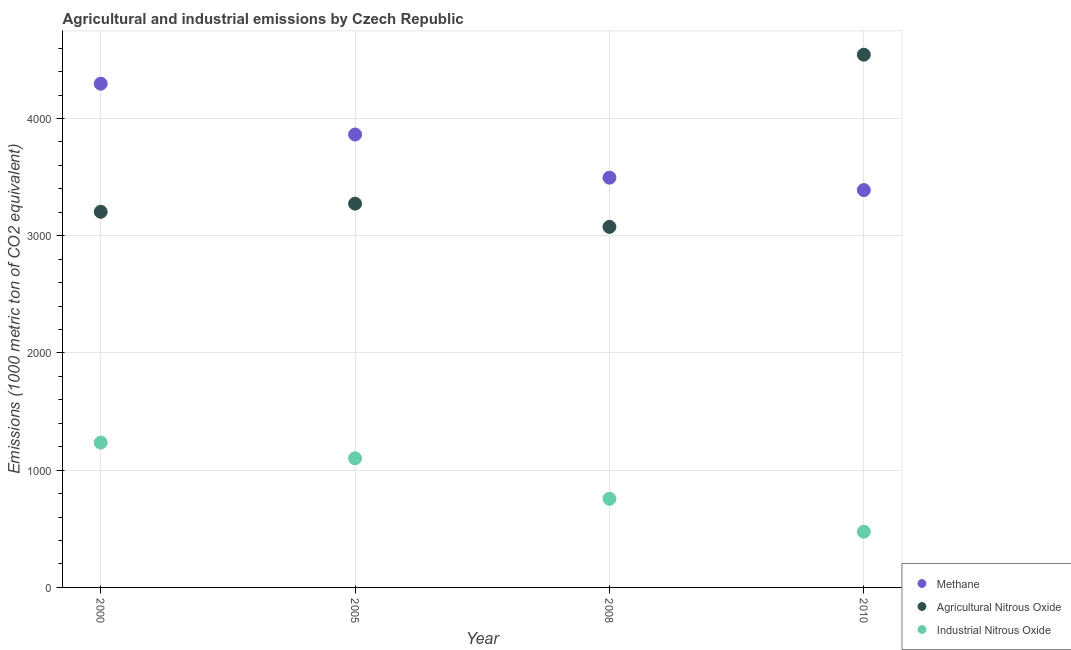Is the number of dotlines equal to the number of legend labels?
Make the answer very short. Yes. What is the amount of agricultural nitrous oxide emissions in 2000?
Keep it short and to the point. 3204.1. Across all years, what is the maximum amount of methane emissions?
Give a very brief answer. 4296.7. Across all years, what is the minimum amount of industrial nitrous oxide emissions?
Keep it short and to the point. 475.2. In which year was the amount of methane emissions maximum?
Keep it short and to the point. 2000. In which year was the amount of agricultural nitrous oxide emissions minimum?
Provide a short and direct response. 2008. What is the total amount of industrial nitrous oxide emissions in the graph?
Your answer should be very brief. 3568.1. What is the difference between the amount of methane emissions in 2000 and that in 2005?
Keep it short and to the point. 433.3. What is the difference between the amount of industrial nitrous oxide emissions in 2005 and the amount of agricultural nitrous oxide emissions in 2008?
Your answer should be compact. -1974.1. What is the average amount of industrial nitrous oxide emissions per year?
Make the answer very short. 892.02. In the year 2000, what is the difference between the amount of industrial nitrous oxide emissions and amount of agricultural nitrous oxide emissions?
Make the answer very short. -1968.7. What is the ratio of the amount of industrial nitrous oxide emissions in 2005 to that in 2008?
Provide a short and direct response. 1.46. Is the amount of industrial nitrous oxide emissions in 2005 less than that in 2010?
Ensure brevity in your answer.  No. What is the difference between the highest and the second highest amount of methane emissions?
Keep it short and to the point. 433.3. What is the difference between the highest and the lowest amount of industrial nitrous oxide emissions?
Your answer should be very brief. 760.2. In how many years, is the amount of methane emissions greater than the average amount of methane emissions taken over all years?
Your answer should be very brief. 2. Is it the case that in every year, the sum of the amount of methane emissions and amount of agricultural nitrous oxide emissions is greater than the amount of industrial nitrous oxide emissions?
Your answer should be very brief. Yes. Is the amount of agricultural nitrous oxide emissions strictly less than the amount of methane emissions over the years?
Make the answer very short. No. How many years are there in the graph?
Offer a terse response. 4. What is the difference between two consecutive major ticks on the Y-axis?
Offer a very short reply. 1000. Are the values on the major ticks of Y-axis written in scientific E-notation?
Offer a very short reply. No. Does the graph contain any zero values?
Provide a short and direct response. No. Does the graph contain grids?
Your answer should be compact. Yes. Where does the legend appear in the graph?
Your response must be concise. Bottom right. How many legend labels are there?
Offer a terse response. 3. How are the legend labels stacked?
Your answer should be very brief. Vertical. What is the title of the graph?
Keep it short and to the point. Agricultural and industrial emissions by Czech Republic. What is the label or title of the X-axis?
Offer a very short reply. Year. What is the label or title of the Y-axis?
Make the answer very short. Emissions (1000 metric ton of CO2 equivalent). What is the Emissions (1000 metric ton of CO2 equivalent) of Methane in 2000?
Provide a succinct answer. 4296.7. What is the Emissions (1000 metric ton of CO2 equivalent) of Agricultural Nitrous Oxide in 2000?
Your answer should be very brief. 3204.1. What is the Emissions (1000 metric ton of CO2 equivalent) of Industrial Nitrous Oxide in 2000?
Offer a very short reply. 1235.4. What is the Emissions (1000 metric ton of CO2 equivalent) of Methane in 2005?
Offer a terse response. 3863.4. What is the Emissions (1000 metric ton of CO2 equivalent) of Agricultural Nitrous Oxide in 2005?
Your answer should be very brief. 3273.7. What is the Emissions (1000 metric ton of CO2 equivalent) of Industrial Nitrous Oxide in 2005?
Ensure brevity in your answer.  1101.5. What is the Emissions (1000 metric ton of CO2 equivalent) of Methane in 2008?
Keep it short and to the point. 3495.2. What is the Emissions (1000 metric ton of CO2 equivalent) in Agricultural Nitrous Oxide in 2008?
Offer a very short reply. 3075.6. What is the Emissions (1000 metric ton of CO2 equivalent) in Industrial Nitrous Oxide in 2008?
Your answer should be compact. 756. What is the Emissions (1000 metric ton of CO2 equivalent) of Methane in 2010?
Ensure brevity in your answer.  3389.3. What is the Emissions (1000 metric ton of CO2 equivalent) of Agricultural Nitrous Oxide in 2010?
Provide a succinct answer. 4544.3. What is the Emissions (1000 metric ton of CO2 equivalent) in Industrial Nitrous Oxide in 2010?
Ensure brevity in your answer.  475.2. Across all years, what is the maximum Emissions (1000 metric ton of CO2 equivalent) in Methane?
Offer a terse response. 4296.7. Across all years, what is the maximum Emissions (1000 metric ton of CO2 equivalent) in Agricultural Nitrous Oxide?
Keep it short and to the point. 4544.3. Across all years, what is the maximum Emissions (1000 metric ton of CO2 equivalent) of Industrial Nitrous Oxide?
Provide a short and direct response. 1235.4. Across all years, what is the minimum Emissions (1000 metric ton of CO2 equivalent) of Methane?
Your answer should be compact. 3389.3. Across all years, what is the minimum Emissions (1000 metric ton of CO2 equivalent) in Agricultural Nitrous Oxide?
Keep it short and to the point. 3075.6. Across all years, what is the minimum Emissions (1000 metric ton of CO2 equivalent) in Industrial Nitrous Oxide?
Keep it short and to the point. 475.2. What is the total Emissions (1000 metric ton of CO2 equivalent) in Methane in the graph?
Your answer should be very brief. 1.50e+04. What is the total Emissions (1000 metric ton of CO2 equivalent) of Agricultural Nitrous Oxide in the graph?
Provide a succinct answer. 1.41e+04. What is the total Emissions (1000 metric ton of CO2 equivalent) of Industrial Nitrous Oxide in the graph?
Make the answer very short. 3568.1. What is the difference between the Emissions (1000 metric ton of CO2 equivalent) in Methane in 2000 and that in 2005?
Offer a terse response. 433.3. What is the difference between the Emissions (1000 metric ton of CO2 equivalent) of Agricultural Nitrous Oxide in 2000 and that in 2005?
Provide a succinct answer. -69.6. What is the difference between the Emissions (1000 metric ton of CO2 equivalent) of Industrial Nitrous Oxide in 2000 and that in 2005?
Make the answer very short. 133.9. What is the difference between the Emissions (1000 metric ton of CO2 equivalent) in Methane in 2000 and that in 2008?
Provide a short and direct response. 801.5. What is the difference between the Emissions (1000 metric ton of CO2 equivalent) in Agricultural Nitrous Oxide in 2000 and that in 2008?
Offer a terse response. 128.5. What is the difference between the Emissions (1000 metric ton of CO2 equivalent) in Industrial Nitrous Oxide in 2000 and that in 2008?
Offer a very short reply. 479.4. What is the difference between the Emissions (1000 metric ton of CO2 equivalent) of Methane in 2000 and that in 2010?
Give a very brief answer. 907.4. What is the difference between the Emissions (1000 metric ton of CO2 equivalent) in Agricultural Nitrous Oxide in 2000 and that in 2010?
Give a very brief answer. -1340.2. What is the difference between the Emissions (1000 metric ton of CO2 equivalent) in Industrial Nitrous Oxide in 2000 and that in 2010?
Make the answer very short. 760.2. What is the difference between the Emissions (1000 metric ton of CO2 equivalent) of Methane in 2005 and that in 2008?
Ensure brevity in your answer.  368.2. What is the difference between the Emissions (1000 metric ton of CO2 equivalent) of Agricultural Nitrous Oxide in 2005 and that in 2008?
Offer a very short reply. 198.1. What is the difference between the Emissions (1000 metric ton of CO2 equivalent) of Industrial Nitrous Oxide in 2005 and that in 2008?
Keep it short and to the point. 345.5. What is the difference between the Emissions (1000 metric ton of CO2 equivalent) of Methane in 2005 and that in 2010?
Ensure brevity in your answer.  474.1. What is the difference between the Emissions (1000 metric ton of CO2 equivalent) in Agricultural Nitrous Oxide in 2005 and that in 2010?
Provide a short and direct response. -1270.6. What is the difference between the Emissions (1000 metric ton of CO2 equivalent) of Industrial Nitrous Oxide in 2005 and that in 2010?
Offer a terse response. 626.3. What is the difference between the Emissions (1000 metric ton of CO2 equivalent) in Methane in 2008 and that in 2010?
Make the answer very short. 105.9. What is the difference between the Emissions (1000 metric ton of CO2 equivalent) of Agricultural Nitrous Oxide in 2008 and that in 2010?
Offer a very short reply. -1468.7. What is the difference between the Emissions (1000 metric ton of CO2 equivalent) in Industrial Nitrous Oxide in 2008 and that in 2010?
Ensure brevity in your answer.  280.8. What is the difference between the Emissions (1000 metric ton of CO2 equivalent) in Methane in 2000 and the Emissions (1000 metric ton of CO2 equivalent) in Agricultural Nitrous Oxide in 2005?
Your response must be concise. 1023. What is the difference between the Emissions (1000 metric ton of CO2 equivalent) of Methane in 2000 and the Emissions (1000 metric ton of CO2 equivalent) of Industrial Nitrous Oxide in 2005?
Your response must be concise. 3195.2. What is the difference between the Emissions (1000 metric ton of CO2 equivalent) in Agricultural Nitrous Oxide in 2000 and the Emissions (1000 metric ton of CO2 equivalent) in Industrial Nitrous Oxide in 2005?
Keep it short and to the point. 2102.6. What is the difference between the Emissions (1000 metric ton of CO2 equivalent) of Methane in 2000 and the Emissions (1000 metric ton of CO2 equivalent) of Agricultural Nitrous Oxide in 2008?
Provide a short and direct response. 1221.1. What is the difference between the Emissions (1000 metric ton of CO2 equivalent) of Methane in 2000 and the Emissions (1000 metric ton of CO2 equivalent) of Industrial Nitrous Oxide in 2008?
Provide a succinct answer. 3540.7. What is the difference between the Emissions (1000 metric ton of CO2 equivalent) in Agricultural Nitrous Oxide in 2000 and the Emissions (1000 metric ton of CO2 equivalent) in Industrial Nitrous Oxide in 2008?
Give a very brief answer. 2448.1. What is the difference between the Emissions (1000 metric ton of CO2 equivalent) of Methane in 2000 and the Emissions (1000 metric ton of CO2 equivalent) of Agricultural Nitrous Oxide in 2010?
Give a very brief answer. -247.6. What is the difference between the Emissions (1000 metric ton of CO2 equivalent) of Methane in 2000 and the Emissions (1000 metric ton of CO2 equivalent) of Industrial Nitrous Oxide in 2010?
Your answer should be very brief. 3821.5. What is the difference between the Emissions (1000 metric ton of CO2 equivalent) of Agricultural Nitrous Oxide in 2000 and the Emissions (1000 metric ton of CO2 equivalent) of Industrial Nitrous Oxide in 2010?
Your answer should be compact. 2728.9. What is the difference between the Emissions (1000 metric ton of CO2 equivalent) in Methane in 2005 and the Emissions (1000 metric ton of CO2 equivalent) in Agricultural Nitrous Oxide in 2008?
Ensure brevity in your answer.  787.8. What is the difference between the Emissions (1000 metric ton of CO2 equivalent) in Methane in 2005 and the Emissions (1000 metric ton of CO2 equivalent) in Industrial Nitrous Oxide in 2008?
Ensure brevity in your answer.  3107.4. What is the difference between the Emissions (1000 metric ton of CO2 equivalent) in Agricultural Nitrous Oxide in 2005 and the Emissions (1000 metric ton of CO2 equivalent) in Industrial Nitrous Oxide in 2008?
Your response must be concise. 2517.7. What is the difference between the Emissions (1000 metric ton of CO2 equivalent) in Methane in 2005 and the Emissions (1000 metric ton of CO2 equivalent) in Agricultural Nitrous Oxide in 2010?
Give a very brief answer. -680.9. What is the difference between the Emissions (1000 metric ton of CO2 equivalent) in Methane in 2005 and the Emissions (1000 metric ton of CO2 equivalent) in Industrial Nitrous Oxide in 2010?
Your answer should be compact. 3388.2. What is the difference between the Emissions (1000 metric ton of CO2 equivalent) in Agricultural Nitrous Oxide in 2005 and the Emissions (1000 metric ton of CO2 equivalent) in Industrial Nitrous Oxide in 2010?
Keep it short and to the point. 2798.5. What is the difference between the Emissions (1000 metric ton of CO2 equivalent) in Methane in 2008 and the Emissions (1000 metric ton of CO2 equivalent) in Agricultural Nitrous Oxide in 2010?
Provide a short and direct response. -1049.1. What is the difference between the Emissions (1000 metric ton of CO2 equivalent) of Methane in 2008 and the Emissions (1000 metric ton of CO2 equivalent) of Industrial Nitrous Oxide in 2010?
Provide a succinct answer. 3020. What is the difference between the Emissions (1000 metric ton of CO2 equivalent) in Agricultural Nitrous Oxide in 2008 and the Emissions (1000 metric ton of CO2 equivalent) in Industrial Nitrous Oxide in 2010?
Provide a succinct answer. 2600.4. What is the average Emissions (1000 metric ton of CO2 equivalent) in Methane per year?
Your answer should be compact. 3761.15. What is the average Emissions (1000 metric ton of CO2 equivalent) of Agricultural Nitrous Oxide per year?
Provide a succinct answer. 3524.43. What is the average Emissions (1000 metric ton of CO2 equivalent) of Industrial Nitrous Oxide per year?
Offer a very short reply. 892.02. In the year 2000, what is the difference between the Emissions (1000 metric ton of CO2 equivalent) in Methane and Emissions (1000 metric ton of CO2 equivalent) in Agricultural Nitrous Oxide?
Keep it short and to the point. 1092.6. In the year 2000, what is the difference between the Emissions (1000 metric ton of CO2 equivalent) of Methane and Emissions (1000 metric ton of CO2 equivalent) of Industrial Nitrous Oxide?
Offer a very short reply. 3061.3. In the year 2000, what is the difference between the Emissions (1000 metric ton of CO2 equivalent) in Agricultural Nitrous Oxide and Emissions (1000 metric ton of CO2 equivalent) in Industrial Nitrous Oxide?
Your answer should be very brief. 1968.7. In the year 2005, what is the difference between the Emissions (1000 metric ton of CO2 equivalent) in Methane and Emissions (1000 metric ton of CO2 equivalent) in Agricultural Nitrous Oxide?
Keep it short and to the point. 589.7. In the year 2005, what is the difference between the Emissions (1000 metric ton of CO2 equivalent) in Methane and Emissions (1000 metric ton of CO2 equivalent) in Industrial Nitrous Oxide?
Keep it short and to the point. 2761.9. In the year 2005, what is the difference between the Emissions (1000 metric ton of CO2 equivalent) in Agricultural Nitrous Oxide and Emissions (1000 metric ton of CO2 equivalent) in Industrial Nitrous Oxide?
Give a very brief answer. 2172.2. In the year 2008, what is the difference between the Emissions (1000 metric ton of CO2 equivalent) in Methane and Emissions (1000 metric ton of CO2 equivalent) in Agricultural Nitrous Oxide?
Your answer should be compact. 419.6. In the year 2008, what is the difference between the Emissions (1000 metric ton of CO2 equivalent) of Methane and Emissions (1000 metric ton of CO2 equivalent) of Industrial Nitrous Oxide?
Offer a very short reply. 2739.2. In the year 2008, what is the difference between the Emissions (1000 metric ton of CO2 equivalent) of Agricultural Nitrous Oxide and Emissions (1000 metric ton of CO2 equivalent) of Industrial Nitrous Oxide?
Make the answer very short. 2319.6. In the year 2010, what is the difference between the Emissions (1000 metric ton of CO2 equivalent) of Methane and Emissions (1000 metric ton of CO2 equivalent) of Agricultural Nitrous Oxide?
Provide a succinct answer. -1155. In the year 2010, what is the difference between the Emissions (1000 metric ton of CO2 equivalent) of Methane and Emissions (1000 metric ton of CO2 equivalent) of Industrial Nitrous Oxide?
Make the answer very short. 2914.1. In the year 2010, what is the difference between the Emissions (1000 metric ton of CO2 equivalent) of Agricultural Nitrous Oxide and Emissions (1000 metric ton of CO2 equivalent) of Industrial Nitrous Oxide?
Make the answer very short. 4069.1. What is the ratio of the Emissions (1000 metric ton of CO2 equivalent) in Methane in 2000 to that in 2005?
Provide a succinct answer. 1.11. What is the ratio of the Emissions (1000 metric ton of CO2 equivalent) in Agricultural Nitrous Oxide in 2000 to that in 2005?
Offer a very short reply. 0.98. What is the ratio of the Emissions (1000 metric ton of CO2 equivalent) in Industrial Nitrous Oxide in 2000 to that in 2005?
Your answer should be very brief. 1.12. What is the ratio of the Emissions (1000 metric ton of CO2 equivalent) in Methane in 2000 to that in 2008?
Provide a succinct answer. 1.23. What is the ratio of the Emissions (1000 metric ton of CO2 equivalent) of Agricultural Nitrous Oxide in 2000 to that in 2008?
Ensure brevity in your answer.  1.04. What is the ratio of the Emissions (1000 metric ton of CO2 equivalent) in Industrial Nitrous Oxide in 2000 to that in 2008?
Offer a very short reply. 1.63. What is the ratio of the Emissions (1000 metric ton of CO2 equivalent) of Methane in 2000 to that in 2010?
Offer a very short reply. 1.27. What is the ratio of the Emissions (1000 metric ton of CO2 equivalent) in Agricultural Nitrous Oxide in 2000 to that in 2010?
Keep it short and to the point. 0.71. What is the ratio of the Emissions (1000 metric ton of CO2 equivalent) of Industrial Nitrous Oxide in 2000 to that in 2010?
Give a very brief answer. 2.6. What is the ratio of the Emissions (1000 metric ton of CO2 equivalent) in Methane in 2005 to that in 2008?
Keep it short and to the point. 1.11. What is the ratio of the Emissions (1000 metric ton of CO2 equivalent) of Agricultural Nitrous Oxide in 2005 to that in 2008?
Offer a terse response. 1.06. What is the ratio of the Emissions (1000 metric ton of CO2 equivalent) of Industrial Nitrous Oxide in 2005 to that in 2008?
Make the answer very short. 1.46. What is the ratio of the Emissions (1000 metric ton of CO2 equivalent) in Methane in 2005 to that in 2010?
Offer a terse response. 1.14. What is the ratio of the Emissions (1000 metric ton of CO2 equivalent) of Agricultural Nitrous Oxide in 2005 to that in 2010?
Your answer should be compact. 0.72. What is the ratio of the Emissions (1000 metric ton of CO2 equivalent) of Industrial Nitrous Oxide in 2005 to that in 2010?
Offer a very short reply. 2.32. What is the ratio of the Emissions (1000 metric ton of CO2 equivalent) of Methane in 2008 to that in 2010?
Provide a short and direct response. 1.03. What is the ratio of the Emissions (1000 metric ton of CO2 equivalent) of Agricultural Nitrous Oxide in 2008 to that in 2010?
Make the answer very short. 0.68. What is the ratio of the Emissions (1000 metric ton of CO2 equivalent) in Industrial Nitrous Oxide in 2008 to that in 2010?
Provide a succinct answer. 1.59. What is the difference between the highest and the second highest Emissions (1000 metric ton of CO2 equivalent) of Methane?
Your answer should be compact. 433.3. What is the difference between the highest and the second highest Emissions (1000 metric ton of CO2 equivalent) of Agricultural Nitrous Oxide?
Keep it short and to the point. 1270.6. What is the difference between the highest and the second highest Emissions (1000 metric ton of CO2 equivalent) in Industrial Nitrous Oxide?
Keep it short and to the point. 133.9. What is the difference between the highest and the lowest Emissions (1000 metric ton of CO2 equivalent) of Methane?
Make the answer very short. 907.4. What is the difference between the highest and the lowest Emissions (1000 metric ton of CO2 equivalent) of Agricultural Nitrous Oxide?
Keep it short and to the point. 1468.7. What is the difference between the highest and the lowest Emissions (1000 metric ton of CO2 equivalent) in Industrial Nitrous Oxide?
Your answer should be compact. 760.2. 